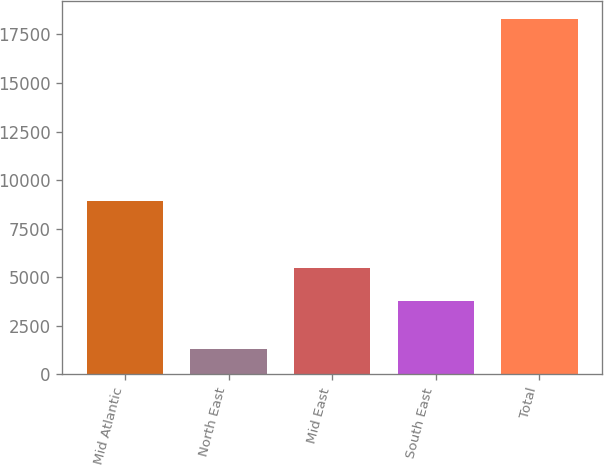Convert chart. <chart><loc_0><loc_0><loc_500><loc_500><bar_chart><fcel>Mid Atlantic<fcel>North East<fcel>Mid East<fcel>South East<fcel>Total<nl><fcel>8906<fcel>1296<fcel>5463.5<fcel>3765<fcel>18281<nl></chart> 